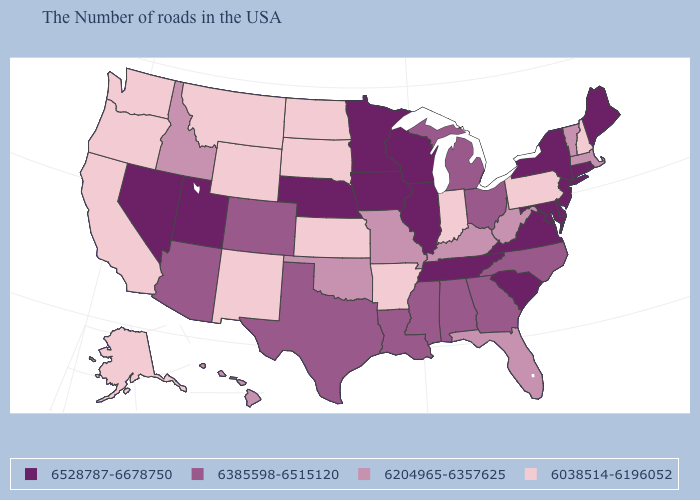Name the states that have a value in the range 6204965-6357625?
Quick response, please. Massachusetts, Vermont, West Virginia, Florida, Kentucky, Missouri, Oklahoma, Idaho, Hawaii. What is the lowest value in the USA?
Concise answer only. 6038514-6196052. Among the states that border New York , which have the lowest value?
Write a very short answer. Pennsylvania. Which states have the lowest value in the USA?
Concise answer only. New Hampshire, Pennsylvania, Indiana, Arkansas, Kansas, South Dakota, North Dakota, Wyoming, New Mexico, Montana, California, Washington, Oregon, Alaska. Among the states that border North Carolina , which have the highest value?
Answer briefly. Virginia, South Carolina, Tennessee. Which states have the highest value in the USA?
Quick response, please. Maine, Rhode Island, Connecticut, New York, New Jersey, Delaware, Maryland, Virginia, South Carolina, Tennessee, Wisconsin, Illinois, Minnesota, Iowa, Nebraska, Utah, Nevada. Does Iowa have the highest value in the USA?
Concise answer only. Yes. What is the value of Michigan?
Answer briefly. 6385598-6515120. Which states hav the highest value in the South?
Short answer required. Delaware, Maryland, Virginia, South Carolina, Tennessee. What is the value of Nevada?
Keep it brief. 6528787-6678750. What is the highest value in the USA?
Short answer required. 6528787-6678750. Which states have the lowest value in the West?
Short answer required. Wyoming, New Mexico, Montana, California, Washington, Oregon, Alaska. Does New York have a higher value than South Dakota?
Give a very brief answer. Yes. Does the map have missing data?
Give a very brief answer. No. Which states have the highest value in the USA?
Quick response, please. Maine, Rhode Island, Connecticut, New York, New Jersey, Delaware, Maryland, Virginia, South Carolina, Tennessee, Wisconsin, Illinois, Minnesota, Iowa, Nebraska, Utah, Nevada. 